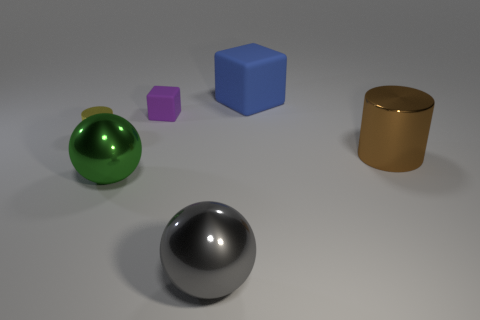What colors are present in the objects? The objects in the image include a variety of colors: there's a green sphere, a purple cube, a blue cube, and a gold-colored cylinder. The sphere in the foreground is silver. 